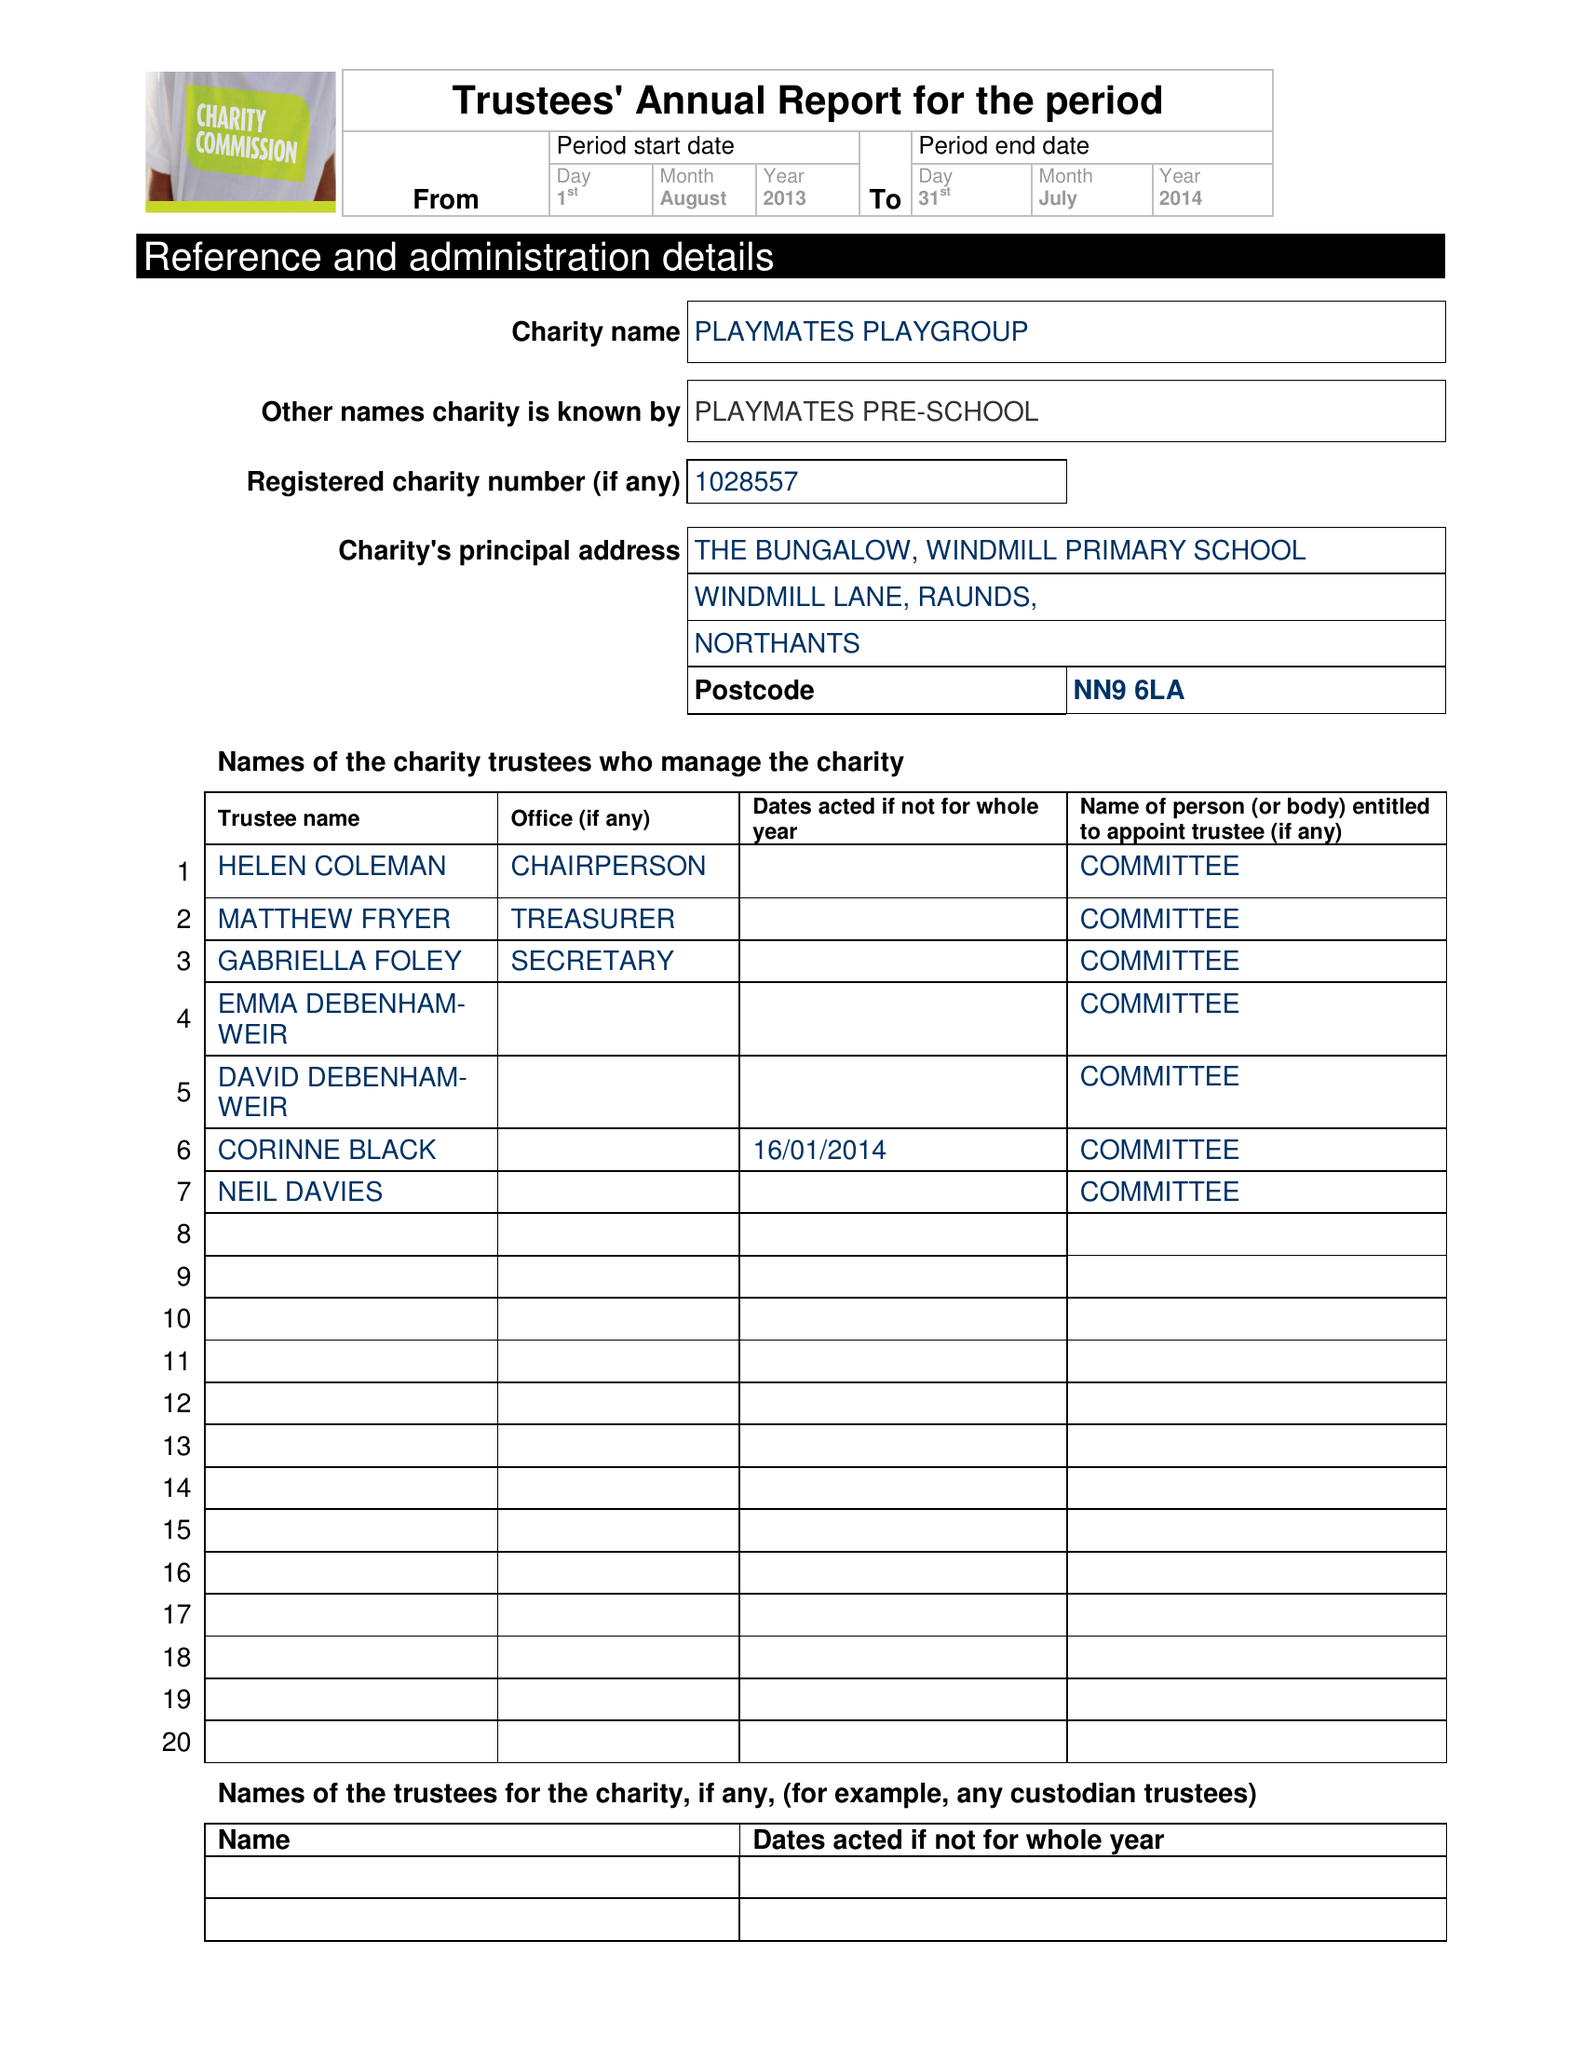What is the value for the charity_name?
Answer the question using a single word or phrase. Playmates Playgroup 